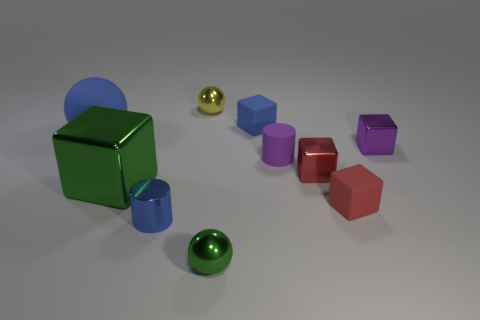Subtract all brown cylinders. How many red cubes are left? 2 Subtract all purple cubes. How many cubes are left? 4 Subtract 1 blocks. How many blocks are left? 4 Subtract all spheres. How many objects are left? 7 Subtract all blue cylinders. How many cylinders are left? 1 Add 3 brown objects. How many brown objects exist? 3 Subtract 0 brown cylinders. How many objects are left? 10 Subtract all yellow cylinders. Subtract all gray balls. How many cylinders are left? 2 Subtract all small metallic cubes. Subtract all yellow things. How many objects are left? 7 Add 1 blue metal cylinders. How many blue metal cylinders are left? 2 